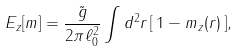<formula> <loc_0><loc_0><loc_500><loc_500>E _ { z } [ { m } ] = \frac { \tilde { g } } { 2 \pi \ell _ { 0 } ^ { 2 } } \int d ^ { 2 } r \, [ \, 1 - m _ { z } ( { r } ) \, ] ,</formula> 